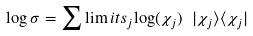<formula> <loc_0><loc_0><loc_500><loc_500>\log \sigma = \sum \lim i t s _ { j } { \log ( \chi _ { j } ) \ | \chi _ { j } \rangle \langle \chi _ { j } | }</formula> 